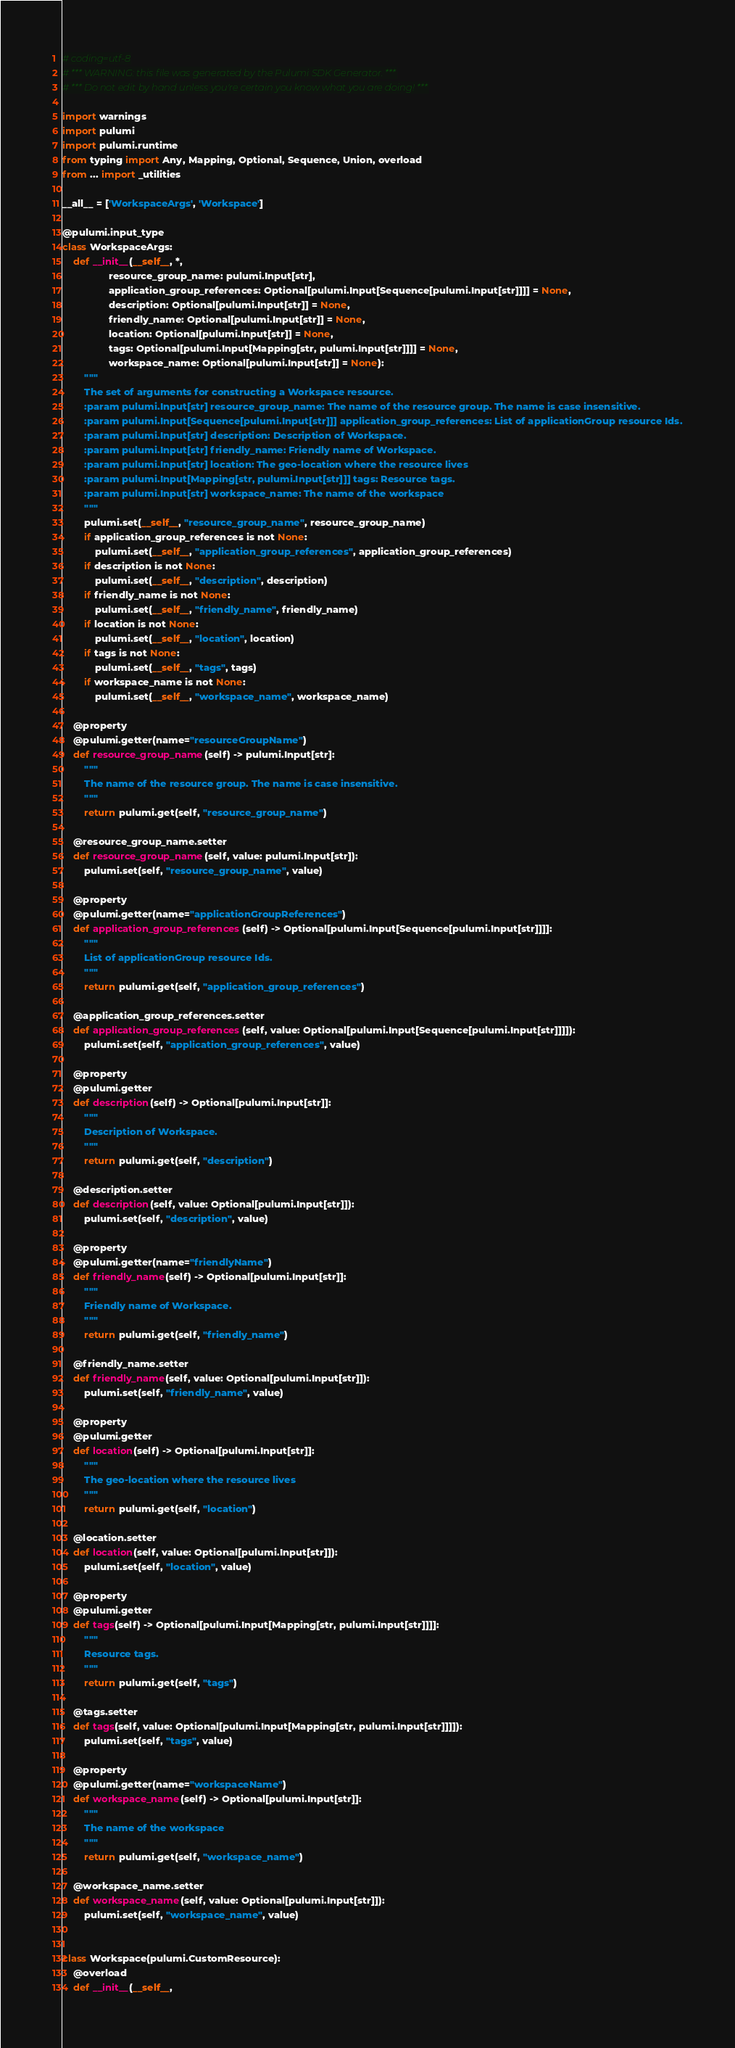Convert code to text. <code><loc_0><loc_0><loc_500><loc_500><_Python_># coding=utf-8
# *** WARNING: this file was generated by the Pulumi SDK Generator. ***
# *** Do not edit by hand unless you're certain you know what you are doing! ***

import warnings
import pulumi
import pulumi.runtime
from typing import Any, Mapping, Optional, Sequence, Union, overload
from ... import _utilities

__all__ = ['WorkspaceArgs', 'Workspace']

@pulumi.input_type
class WorkspaceArgs:
    def __init__(__self__, *,
                 resource_group_name: pulumi.Input[str],
                 application_group_references: Optional[pulumi.Input[Sequence[pulumi.Input[str]]]] = None,
                 description: Optional[pulumi.Input[str]] = None,
                 friendly_name: Optional[pulumi.Input[str]] = None,
                 location: Optional[pulumi.Input[str]] = None,
                 tags: Optional[pulumi.Input[Mapping[str, pulumi.Input[str]]]] = None,
                 workspace_name: Optional[pulumi.Input[str]] = None):
        """
        The set of arguments for constructing a Workspace resource.
        :param pulumi.Input[str] resource_group_name: The name of the resource group. The name is case insensitive.
        :param pulumi.Input[Sequence[pulumi.Input[str]]] application_group_references: List of applicationGroup resource Ids.
        :param pulumi.Input[str] description: Description of Workspace.
        :param pulumi.Input[str] friendly_name: Friendly name of Workspace.
        :param pulumi.Input[str] location: The geo-location where the resource lives
        :param pulumi.Input[Mapping[str, pulumi.Input[str]]] tags: Resource tags.
        :param pulumi.Input[str] workspace_name: The name of the workspace
        """
        pulumi.set(__self__, "resource_group_name", resource_group_name)
        if application_group_references is not None:
            pulumi.set(__self__, "application_group_references", application_group_references)
        if description is not None:
            pulumi.set(__self__, "description", description)
        if friendly_name is not None:
            pulumi.set(__self__, "friendly_name", friendly_name)
        if location is not None:
            pulumi.set(__self__, "location", location)
        if tags is not None:
            pulumi.set(__self__, "tags", tags)
        if workspace_name is not None:
            pulumi.set(__self__, "workspace_name", workspace_name)

    @property
    @pulumi.getter(name="resourceGroupName")
    def resource_group_name(self) -> pulumi.Input[str]:
        """
        The name of the resource group. The name is case insensitive.
        """
        return pulumi.get(self, "resource_group_name")

    @resource_group_name.setter
    def resource_group_name(self, value: pulumi.Input[str]):
        pulumi.set(self, "resource_group_name", value)

    @property
    @pulumi.getter(name="applicationGroupReferences")
    def application_group_references(self) -> Optional[pulumi.Input[Sequence[pulumi.Input[str]]]]:
        """
        List of applicationGroup resource Ids.
        """
        return pulumi.get(self, "application_group_references")

    @application_group_references.setter
    def application_group_references(self, value: Optional[pulumi.Input[Sequence[pulumi.Input[str]]]]):
        pulumi.set(self, "application_group_references", value)

    @property
    @pulumi.getter
    def description(self) -> Optional[pulumi.Input[str]]:
        """
        Description of Workspace.
        """
        return pulumi.get(self, "description")

    @description.setter
    def description(self, value: Optional[pulumi.Input[str]]):
        pulumi.set(self, "description", value)

    @property
    @pulumi.getter(name="friendlyName")
    def friendly_name(self) -> Optional[pulumi.Input[str]]:
        """
        Friendly name of Workspace.
        """
        return pulumi.get(self, "friendly_name")

    @friendly_name.setter
    def friendly_name(self, value: Optional[pulumi.Input[str]]):
        pulumi.set(self, "friendly_name", value)

    @property
    @pulumi.getter
    def location(self) -> Optional[pulumi.Input[str]]:
        """
        The geo-location where the resource lives
        """
        return pulumi.get(self, "location")

    @location.setter
    def location(self, value: Optional[pulumi.Input[str]]):
        pulumi.set(self, "location", value)

    @property
    @pulumi.getter
    def tags(self) -> Optional[pulumi.Input[Mapping[str, pulumi.Input[str]]]]:
        """
        Resource tags.
        """
        return pulumi.get(self, "tags")

    @tags.setter
    def tags(self, value: Optional[pulumi.Input[Mapping[str, pulumi.Input[str]]]]):
        pulumi.set(self, "tags", value)

    @property
    @pulumi.getter(name="workspaceName")
    def workspace_name(self) -> Optional[pulumi.Input[str]]:
        """
        The name of the workspace
        """
        return pulumi.get(self, "workspace_name")

    @workspace_name.setter
    def workspace_name(self, value: Optional[pulumi.Input[str]]):
        pulumi.set(self, "workspace_name", value)


class Workspace(pulumi.CustomResource):
    @overload
    def __init__(__self__,</code> 